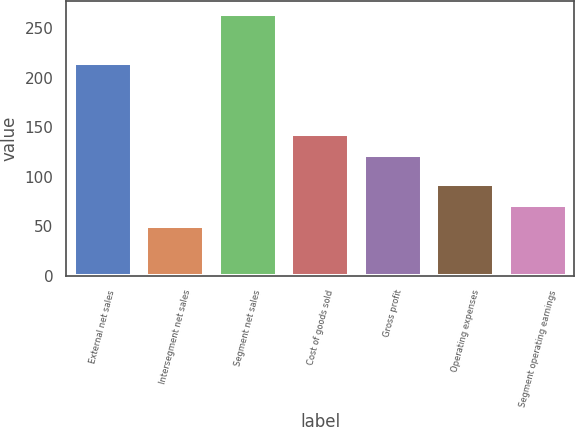Convert chart. <chart><loc_0><loc_0><loc_500><loc_500><bar_chart><fcel>External net sales<fcel>Intersegment net sales<fcel>Segment net sales<fcel>Cost of goods sold<fcel>Gross profit<fcel>Operating expenses<fcel>Segment operating earnings<nl><fcel>214.8<fcel>49.8<fcel>264.6<fcel>143.48<fcel>122<fcel>92.76<fcel>71.28<nl></chart> 